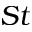Convert formula to latex. <formula><loc_0><loc_0><loc_500><loc_500>S t</formula> 